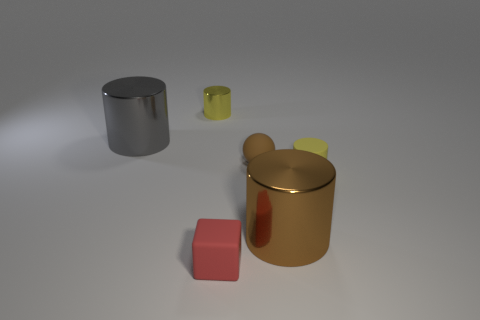There is a shiny cylinder that is the same color as the rubber cylinder; what is its size?
Give a very brief answer. Small. What is the material of the cylinder that is in front of the tiny yellow object that is to the right of the small yellow metal cylinder?
Make the answer very short. Metal. There is a brown object that is behind the metal cylinder that is on the right side of the red thing; what number of objects are on the right side of it?
Offer a very short reply. 2. Is the yellow thing that is on the right side of the big brown metallic thing made of the same material as the tiny cylinder on the left side of the brown matte sphere?
Keep it short and to the point. No. What is the material of the large object that is the same color as the small matte ball?
Offer a terse response. Metal. How many gray metal objects have the same shape as the large brown object?
Your answer should be very brief. 1. Is the number of brown matte spheres in front of the large brown metal cylinder greater than the number of small rubber cylinders?
Make the answer very short. No. There is a yellow thing left of the small red rubber cube in front of the metallic cylinder that is right of the red rubber cube; what is its shape?
Provide a short and direct response. Cylinder. There is a big metallic thing that is on the right side of the gray shiny object; is it the same shape as the tiny thing behind the gray cylinder?
Your response must be concise. Yes. Is there any other thing that is the same size as the red cube?
Ensure brevity in your answer.  Yes. 